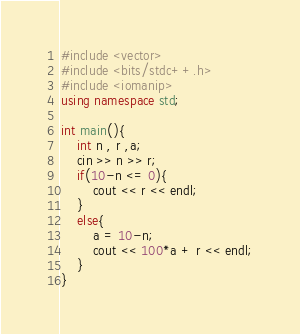Convert code to text. <code><loc_0><loc_0><loc_500><loc_500><_C++_>#include <vector>
#include <bits/stdc++.h>
#include <iomanip>
using namespace std;

int main(){
    int n , r ,a;
    cin >> n >> r;
    if(10-n <= 0){
        cout << r << endl;
    }
    else{
        a = 10-n;
        cout << 100*a + r << endl;
    }
}
</code> 